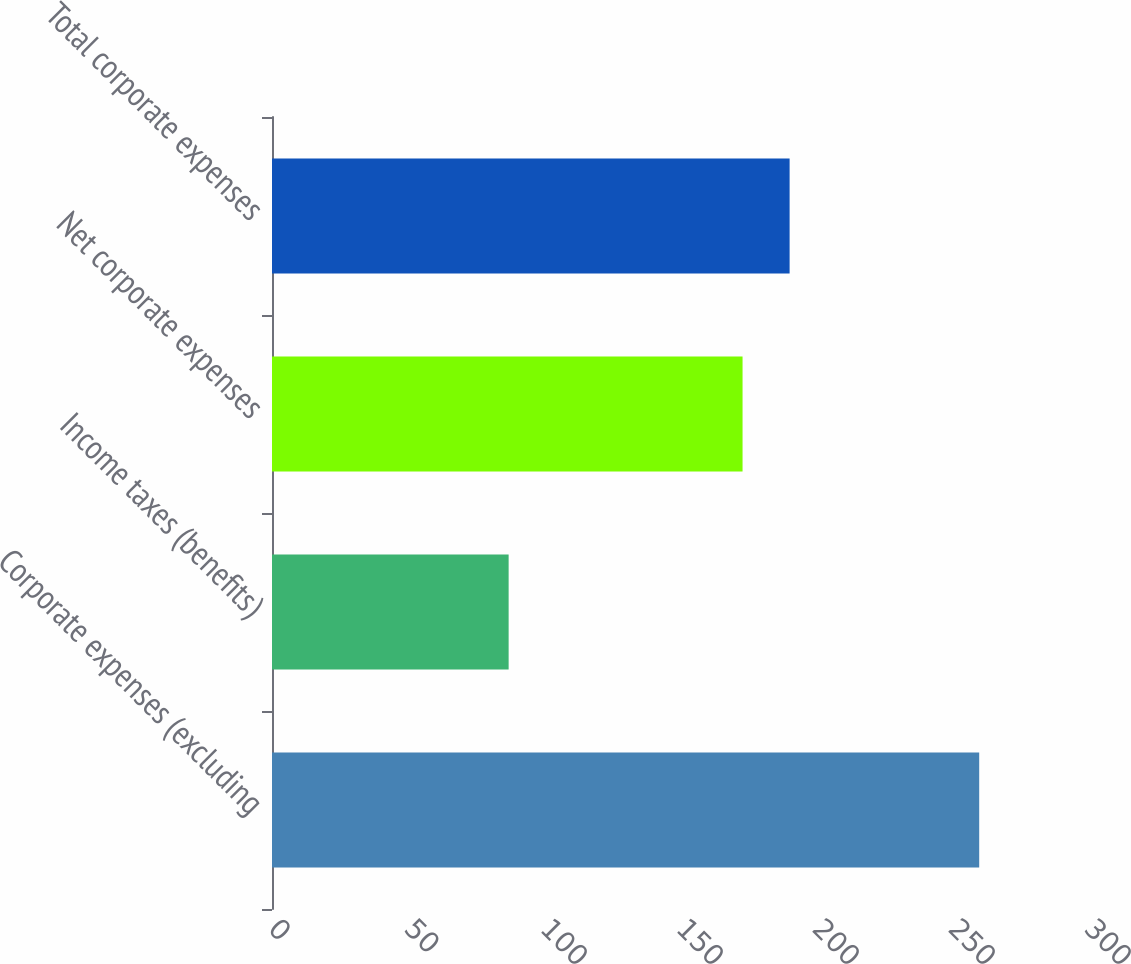Convert chart to OTSL. <chart><loc_0><loc_0><loc_500><loc_500><bar_chart><fcel>Corporate expenses (excluding<fcel>Income taxes (benefits)<fcel>Net corporate expenses<fcel>Total corporate expenses<nl><fcel>260<fcel>87<fcel>173<fcel>190.3<nl></chart> 